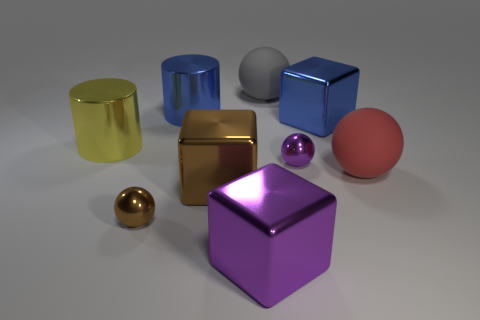What material is the ball that is left of the small purple sphere and in front of the big gray ball? The ball to the left of the small purple sphere and in front of the large gray ball appears to be made of a polished metal, likely brass, given its golden sheen and reflective surface. 